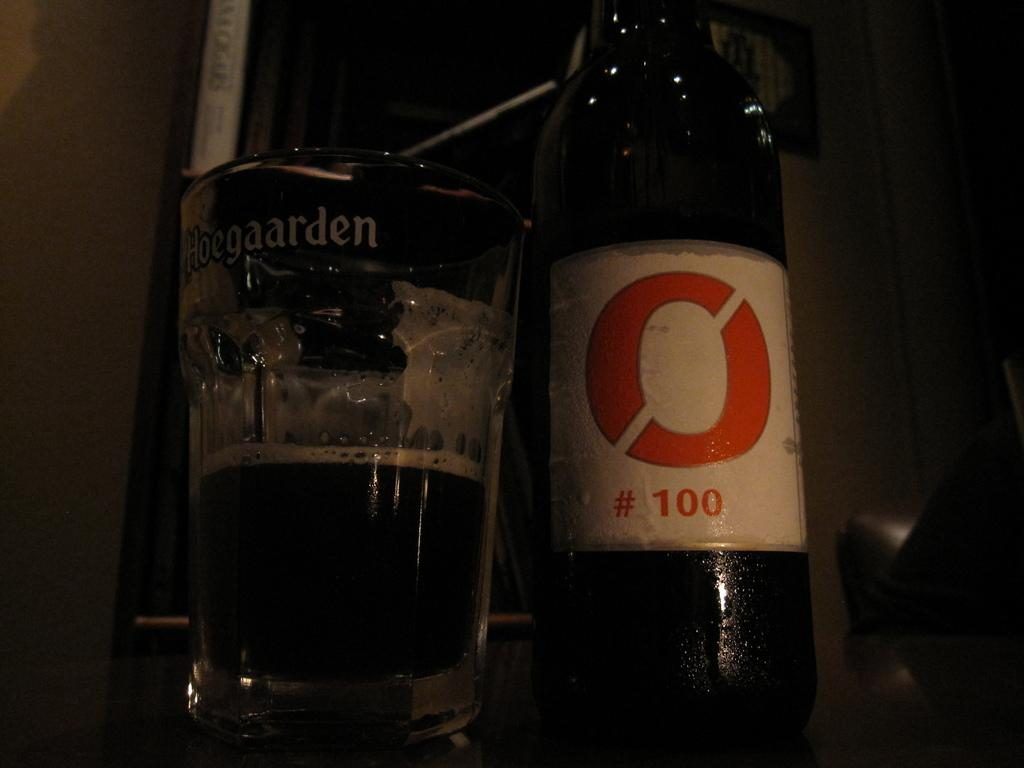Provide a one-sentence caption for the provided image. A glass that says Hoegaarden next to a bottle of beer. 